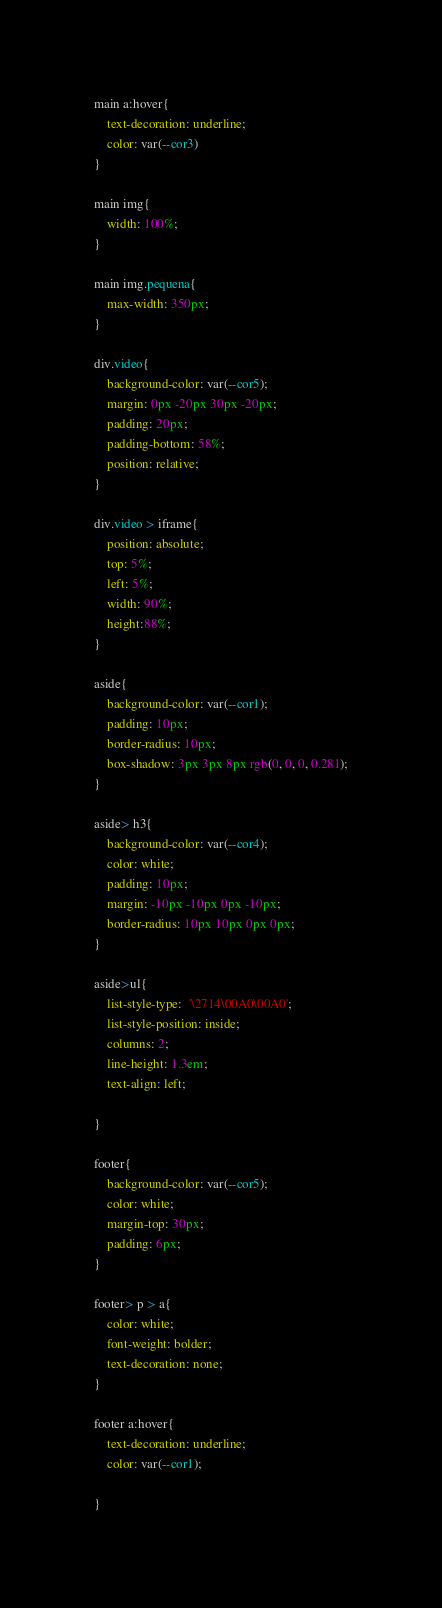Convert code to text. <code><loc_0><loc_0><loc_500><loc_500><_CSS_>main a:hover{
    text-decoration: underline;
    color: var(--cor3)
}

main img{
    width: 100%;
}

main img.pequena{
    max-width: 350px;
}

div.video{
    background-color: var(--cor5);
    margin: 0px -20px 30px -20px;
    padding: 20px;
    padding-bottom: 58%;
    position: relative;
}

div.video > iframe{
    position: absolute;
    top: 5%;
    left: 5%;
    width: 90%;
    height:88%;
}

aside{
    background-color: var(--cor1);
    padding: 10px;
    border-radius: 10px;
    box-shadow: 3px 3px 8px rgb(0, 0, 0, 0.281);
}

aside> h3{
    background-color: var(--cor4);
    color: white;
    padding: 10px;
    margin: -10px -10px 0px -10px;
    border-radius: 10px 10px 0px 0px;
}

aside>ul{
    list-style-type:  '\2714\00A0\00A0';
    list-style-position: inside;
    columns: 2;
    line-height: 1.3em;
    text-align: left;
    
}

footer{
    background-color: var(--cor5);
    color: white;
    margin-top: 30px;
    padding: 6px;
}

footer> p > a{
    color: white;
    font-weight: bolder;
    text-decoration: none;
}

footer a:hover{
    text-decoration: underline;
    color: var(--cor1);
   
}</code> 